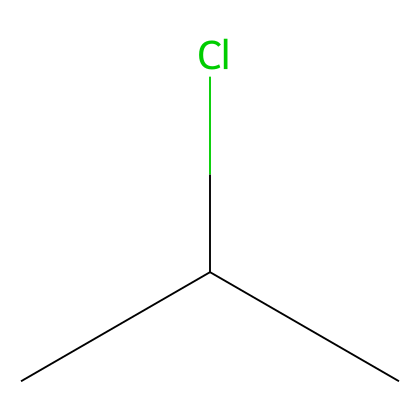What type of chemical structure is represented by the SMILES CC(Cl)C? The SMILES indicates a simple organic molecule with a carbon backbone and a chlorine substituent. It suggests that the compound has a branched structure with three carbon atoms.
Answer: branched alkane How many carbon atoms are in this chemical structure? By analyzing the SMILES, there are two 'C' in the chain plus one in the branching, adding up to a total of three carbon atoms.
Answer: three What functional group is present in this compound based on the SMILES representation? The 'Cl' attached to one of the carbon atoms indicates the presence of a halogen functional group, specifically a chloro group.
Answer: chloro group What is the molecular formula for the compound represented by the SMILES CC(Cl)C? From the analysis of the SMILES, we have three carbon atoms, six hydrogen atoms, and one chlorine atom. This can be combined to form the molecular formula C3H7Cl.
Answer: C3H7Cl Is this structure a polymer or a monomer? This structure consists of a single, small molecule with no repeating units, which characterizes it as a monomer rather than a polymer.
Answer: monomer How many hydrogen atoms are attached to the central carbon atom in this structure? The central carbon is connected to one chlorine atom and two other carbon atoms. Therefore, it can bond with only one additional hydrogen atom to satisfy its tetravalency.
Answer: one Would this structure be suitable for polymerization to create sculpting clays? Yes, the presence of functional groups like chlorine allows for possible polymerization reactions, which can lead to stronger structural properties in sculpting clays.
Answer: yes 